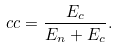Convert formula to latex. <formula><loc_0><loc_0><loc_500><loc_500>c c = \frac { E _ { c } } { E _ { n } + E _ { c } } .</formula> 